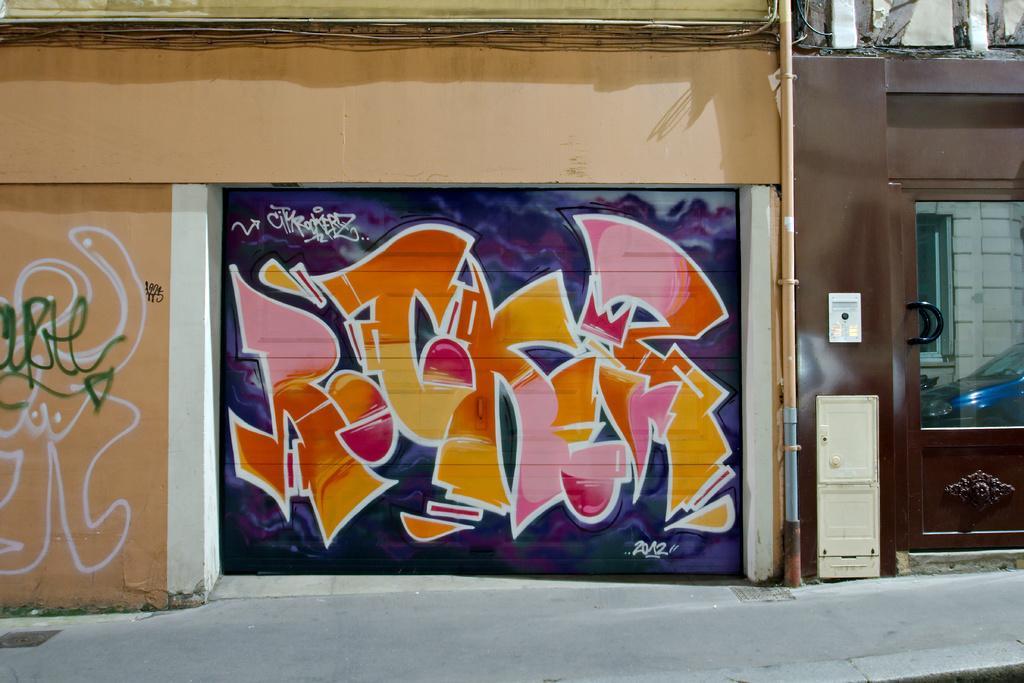In one or two sentences, can you explain what this image depicts? In this image we can see graffiti painting on the walls, on the right side of the image there is a door and we can see the reflection of the car on the glass window. 